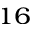Convert formula to latex. <formula><loc_0><loc_0><loc_500><loc_500>^ { 1 6 }</formula> 